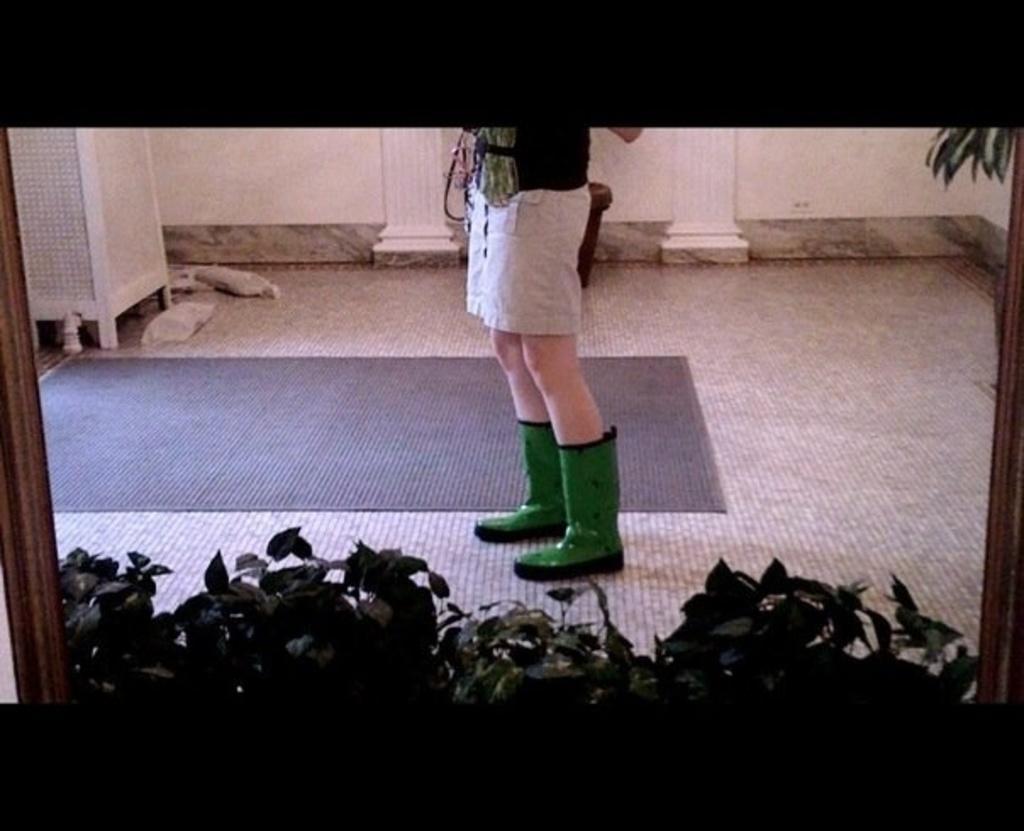How would you summarize this image in a sentence or two? In this image there are plants, there is a person truncated, there is a mat on the floor, there are pillars, there is a wall, there is an object towards the left of the image, there are objects on the floor, there is an object towards the right of the image. 